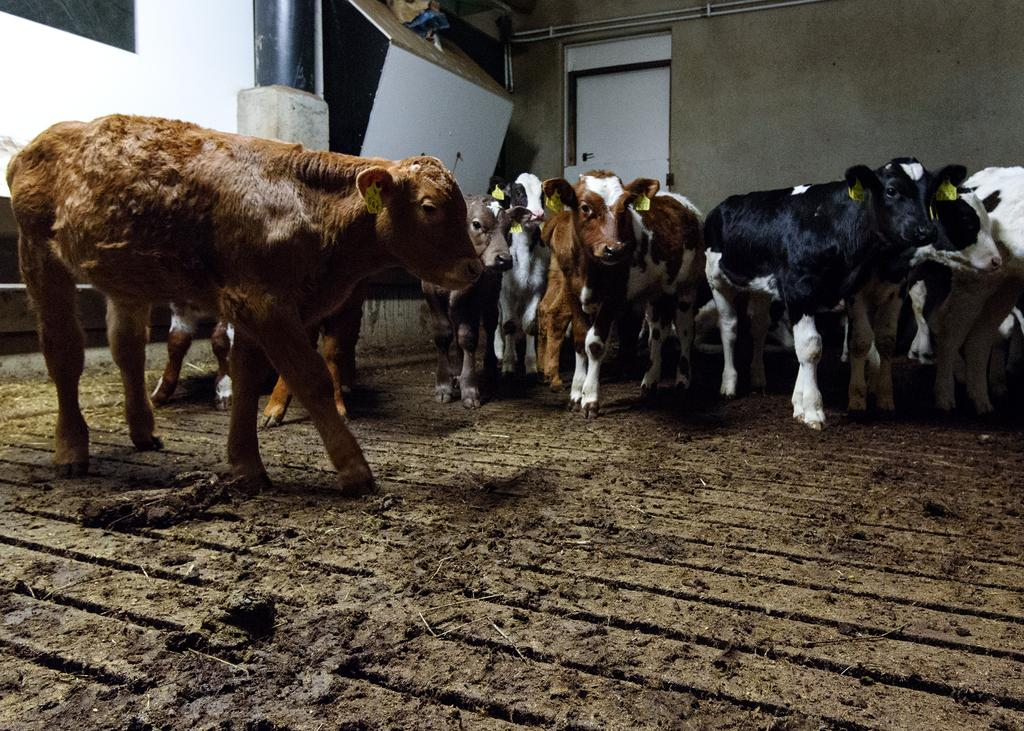What animals can be seen in the image? There are cows in the image. What can be found on the surface in the image? There is dung on the surface in the image. What can be seen in the background of the image? There are objects visible in the background of the image, including a door and pipes on the wall. Where is the playground located in the image? There is no playground present in the image. What type of wind can be seen blowing through the image? There is no wind visible in the image. 